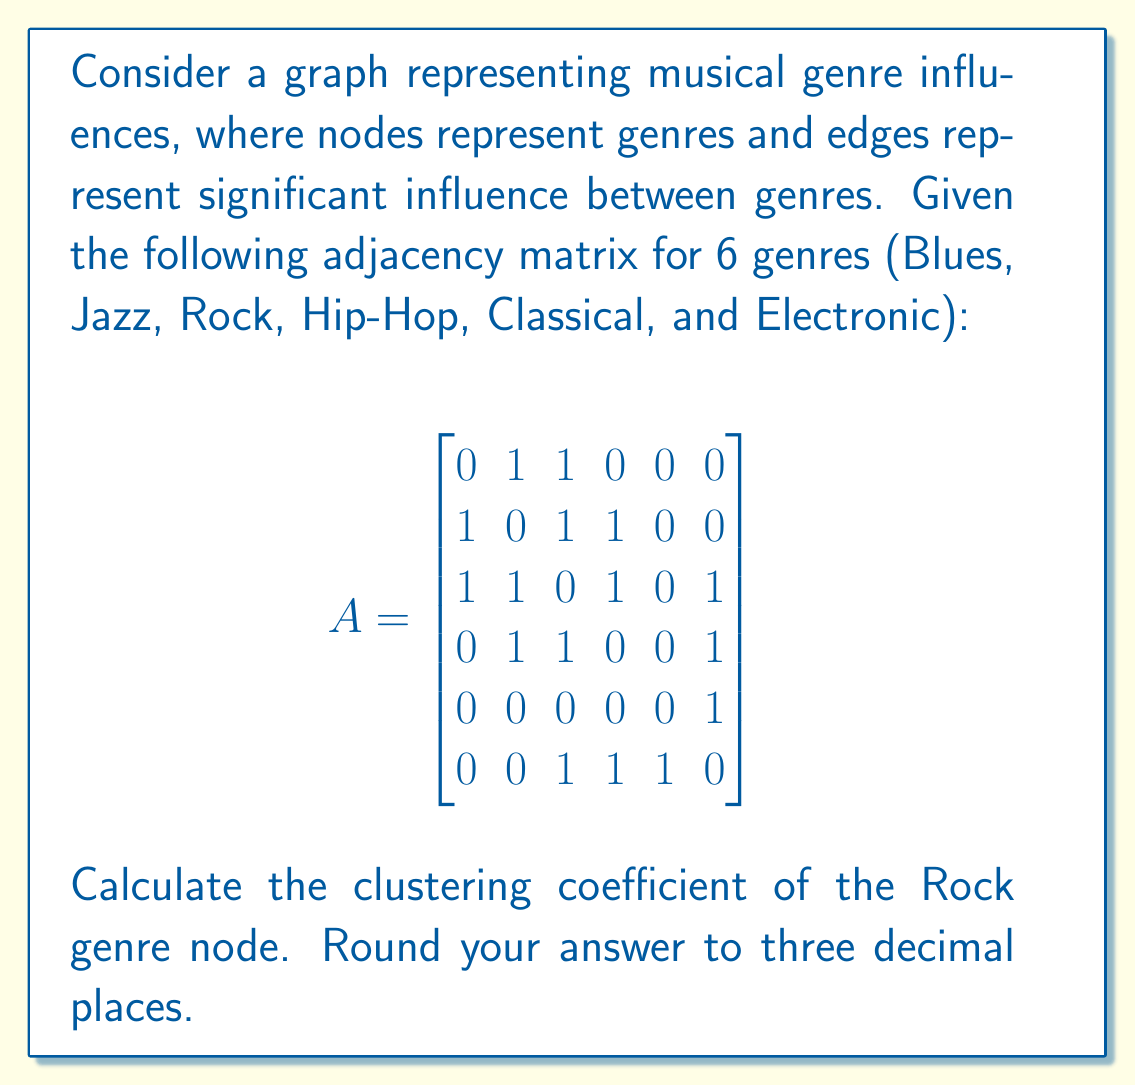Solve this math problem. To solve this problem, we'll follow these steps:

1. Identify the neighbors of the Rock genre node.
2. Count the number of edges between these neighbors.
3. Calculate the maximum possible number of edges between the neighbors.
4. Use the clustering coefficient formula.

Step 1: Identify the neighbors of Rock
From the adjacency matrix, we can see that Rock (row/column 3) is connected to:
- Blues (index 1)
- Jazz (index 2)
- Hip-Hop (index 4)
- Electronic (index 6)

Rock has 4 neighbors.

Step 2: Count edges between neighbors
We need to check the adjacency matrix for connections between these neighbors:
- Blues - Jazz: 1
- Blues - Hip-Hop: 0
- Blues - Electronic: 0
- Jazz - Hip-Hop: 1
- Jazz - Electronic: 0
- Hip-Hop - Electronic: 1

Total edges between neighbors = 3

Step 3: Calculate maximum possible edges
For n neighbors, the maximum number of edges is:
$$ \frac{n(n-1)}{2} $$

With 4 neighbors: $\frac{4(4-1)}{2} = 6$

Step 4: Calculate clustering coefficient
The clustering coefficient is defined as:

$$ C = \frac{2 \times \text{actual edges}}{\text{number of neighbors} \times (\text{number of neighbors} - 1)} $$

Plugging in our values:

$$ C = \frac{2 \times 3}{4 \times (4-1)} = \frac{6}{12} = 0.5 $$

Rounded to three decimal places: 0.500
Answer: 0.500 